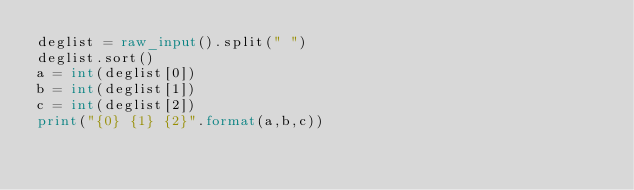Convert code to text. <code><loc_0><loc_0><loc_500><loc_500><_Python_>deglist = raw_input().split(" ")
deglist.sort()
a = int(deglist[0])
b = int(deglist[1])
c = int(deglist[2])
print("{0} {1} {2}".format(a,b,c))</code> 